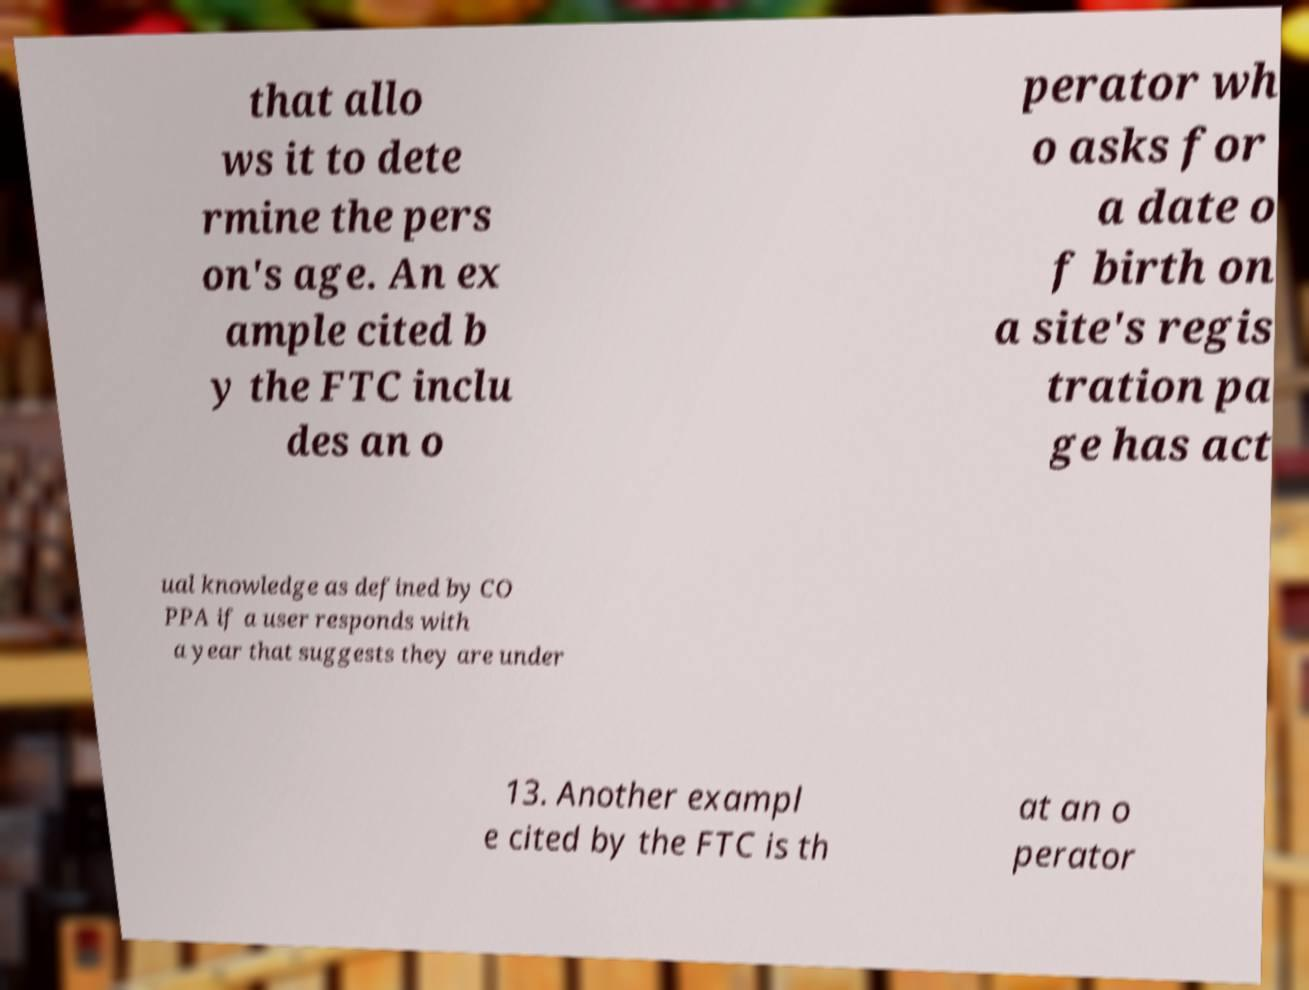Please read and relay the text visible in this image. What does it say? that allo ws it to dete rmine the pers on's age. An ex ample cited b y the FTC inclu des an o perator wh o asks for a date o f birth on a site's regis tration pa ge has act ual knowledge as defined by CO PPA if a user responds with a year that suggests they are under 13. Another exampl e cited by the FTC is th at an o perator 